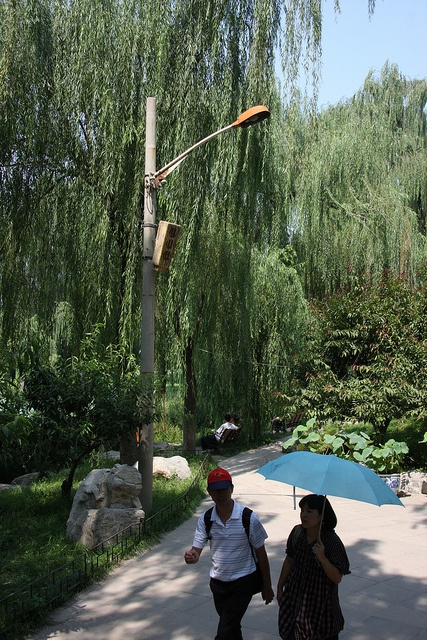Describe the objects in this image and their specific colors. I can see people in gray, black, lightgray, and darkgray tones, people in gray, black, and darkblue tones, umbrella in gray, lightblue, lightgray, and black tones, backpack in gray, black, and darkblue tones, and bench in gray, black, and maroon tones in this image. 